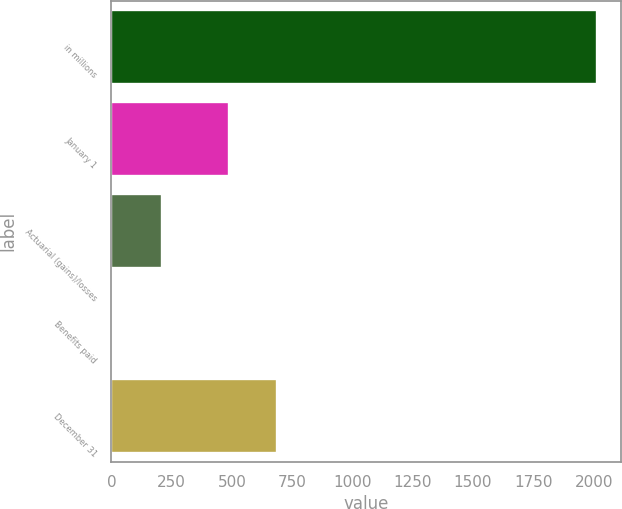Convert chart. <chart><loc_0><loc_0><loc_500><loc_500><bar_chart><fcel>in millions<fcel>January 1<fcel>Actuarial (gains)/losses<fcel>Benefits paid<fcel>December 31<nl><fcel>2014<fcel>486.2<fcel>208.6<fcel>8<fcel>686.8<nl></chart> 